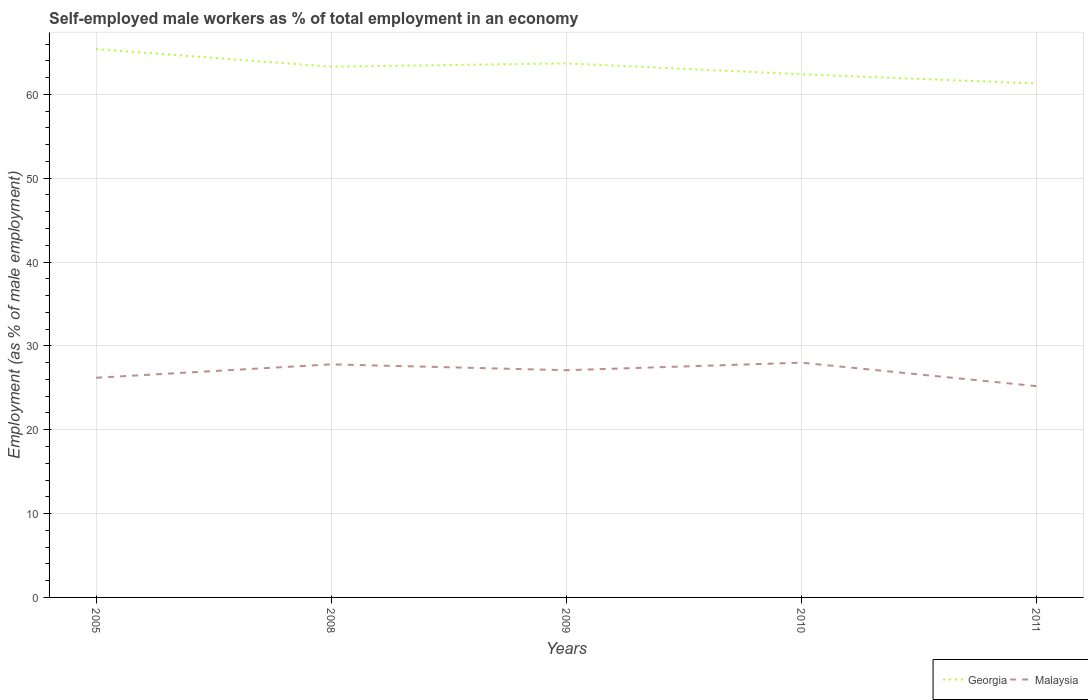Does the line corresponding to Georgia intersect with the line corresponding to Malaysia?
Offer a very short reply. No. Is the number of lines equal to the number of legend labels?
Ensure brevity in your answer.  Yes. Across all years, what is the maximum percentage of self-employed male workers in Malaysia?
Offer a very short reply. 25.2. In which year was the percentage of self-employed male workers in Malaysia maximum?
Your response must be concise. 2011. What is the total percentage of self-employed male workers in Georgia in the graph?
Ensure brevity in your answer.  2.1. What is the difference between the highest and the second highest percentage of self-employed male workers in Georgia?
Your response must be concise. 4.1. How many lines are there?
Offer a terse response. 2. Does the graph contain grids?
Provide a short and direct response. Yes. Where does the legend appear in the graph?
Offer a very short reply. Bottom right. What is the title of the graph?
Your answer should be compact. Self-employed male workers as % of total employment in an economy. Does "South Africa" appear as one of the legend labels in the graph?
Make the answer very short. No. What is the label or title of the X-axis?
Give a very brief answer. Years. What is the label or title of the Y-axis?
Provide a short and direct response. Employment (as % of male employment). What is the Employment (as % of male employment) of Georgia in 2005?
Your answer should be compact. 65.4. What is the Employment (as % of male employment) of Malaysia in 2005?
Ensure brevity in your answer.  26.2. What is the Employment (as % of male employment) of Georgia in 2008?
Offer a terse response. 63.3. What is the Employment (as % of male employment) in Malaysia in 2008?
Provide a short and direct response. 27.8. What is the Employment (as % of male employment) in Georgia in 2009?
Your response must be concise. 63.7. What is the Employment (as % of male employment) of Malaysia in 2009?
Provide a short and direct response. 27.1. What is the Employment (as % of male employment) of Georgia in 2010?
Keep it short and to the point. 62.4. What is the Employment (as % of male employment) of Georgia in 2011?
Provide a succinct answer. 61.3. What is the Employment (as % of male employment) of Malaysia in 2011?
Your response must be concise. 25.2. Across all years, what is the maximum Employment (as % of male employment) in Georgia?
Your answer should be very brief. 65.4. Across all years, what is the minimum Employment (as % of male employment) of Georgia?
Give a very brief answer. 61.3. Across all years, what is the minimum Employment (as % of male employment) in Malaysia?
Make the answer very short. 25.2. What is the total Employment (as % of male employment) in Georgia in the graph?
Your answer should be compact. 316.1. What is the total Employment (as % of male employment) of Malaysia in the graph?
Provide a short and direct response. 134.3. What is the difference between the Employment (as % of male employment) of Georgia in 2005 and that in 2008?
Give a very brief answer. 2.1. What is the difference between the Employment (as % of male employment) in Malaysia in 2005 and that in 2009?
Provide a short and direct response. -0.9. What is the difference between the Employment (as % of male employment) of Malaysia in 2005 and that in 2010?
Your answer should be compact. -1.8. What is the difference between the Employment (as % of male employment) of Malaysia in 2005 and that in 2011?
Keep it short and to the point. 1. What is the difference between the Employment (as % of male employment) in Georgia in 2008 and that in 2009?
Give a very brief answer. -0.4. What is the difference between the Employment (as % of male employment) in Georgia in 2008 and that in 2010?
Provide a succinct answer. 0.9. What is the difference between the Employment (as % of male employment) in Georgia in 2008 and that in 2011?
Provide a succinct answer. 2. What is the difference between the Employment (as % of male employment) in Malaysia in 2009 and that in 2011?
Your response must be concise. 1.9. What is the difference between the Employment (as % of male employment) in Georgia in 2005 and the Employment (as % of male employment) in Malaysia in 2008?
Keep it short and to the point. 37.6. What is the difference between the Employment (as % of male employment) of Georgia in 2005 and the Employment (as % of male employment) of Malaysia in 2009?
Offer a very short reply. 38.3. What is the difference between the Employment (as % of male employment) of Georgia in 2005 and the Employment (as % of male employment) of Malaysia in 2010?
Your answer should be very brief. 37.4. What is the difference between the Employment (as % of male employment) in Georgia in 2005 and the Employment (as % of male employment) in Malaysia in 2011?
Make the answer very short. 40.2. What is the difference between the Employment (as % of male employment) of Georgia in 2008 and the Employment (as % of male employment) of Malaysia in 2009?
Provide a short and direct response. 36.2. What is the difference between the Employment (as % of male employment) in Georgia in 2008 and the Employment (as % of male employment) in Malaysia in 2010?
Your answer should be very brief. 35.3. What is the difference between the Employment (as % of male employment) of Georgia in 2008 and the Employment (as % of male employment) of Malaysia in 2011?
Provide a succinct answer. 38.1. What is the difference between the Employment (as % of male employment) in Georgia in 2009 and the Employment (as % of male employment) in Malaysia in 2010?
Ensure brevity in your answer.  35.7. What is the difference between the Employment (as % of male employment) in Georgia in 2009 and the Employment (as % of male employment) in Malaysia in 2011?
Keep it short and to the point. 38.5. What is the difference between the Employment (as % of male employment) in Georgia in 2010 and the Employment (as % of male employment) in Malaysia in 2011?
Offer a terse response. 37.2. What is the average Employment (as % of male employment) of Georgia per year?
Offer a very short reply. 63.22. What is the average Employment (as % of male employment) of Malaysia per year?
Keep it short and to the point. 26.86. In the year 2005, what is the difference between the Employment (as % of male employment) of Georgia and Employment (as % of male employment) of Malaysia?
Your response must be concise. 39.2. In the year 2008, what is the difference between the Employment (as % of male employment) in Georgia and Employment (as % of male employment) in Malaysia?
Make the answer very short. 35.5. In the year 2009, what is the difference between the Employment (as % of male employment) of Georgia and Employment (as % of male employment) of Malaysia?
Your response must be concise. 36.6. In the year 2010, what is the difference between the Employment (as % of male employment) in Georgia and Employment (as % of male employment) in Malaysia?
Ensure brevity in your answer.  34.4. In the year 2011, what is the difference between the Employment (as % of male employment) in Georgia and Employment (as % of male employment) in Malaysia?
Make the answer very short. 36.1. What is the ratio of the Employment (as % of male employment) of Georgia in 2005 to that in 2008?
Your response must be concise. 1.03. What is the ratio of the Employment (as % of male employment) of Malaysia in 2005 to that in 2008?
Provide a short and direct response. 0.94. What is the ratio of the Employment (as % of male employment) in Georgia in 2005 to that in 2009?
Your answer should be very brief. 1.03. What is the ratio of the Employment (as % of male employment) of Malaysia in 2005 to that in 2009?
Provide a succinct answer. 0.97. What is the ratio of the Employment (as % of male employment) of Georgia in 2005 to that in 2010?
Your answer should be very brief. 1.05. What is the ratio of the Employment (as % of male employment) of Malaysia in 2005 to that in 2010?
Provide a short and direct response. 0.94. What is the ratio of the Employment (as % of male employment) in Georgia in 2005 to that in 2011?
Your response must be concise. 1.07. What is the ratio of the Employment (as % of male employment) of Malaysia in 2005 to that in 2011?
Offer a terse response. 1.04. What is the ratio of the Employment (as % of male employment) in Malaysia in 2008 to that in 2009?
Your answer should be compact. 1.03. What is the ratio of the Employment (as % of male employment) of Georgia in 2008 to that in 2010?
Offer a terse response. 1.01. What is the ratio of the Employment (as % of male employment) in Georgia in 2008 to that in 2011?
Give a very brief answer. 1.03. What is the ratio of the Employment (as % of male employment) in Malaysia in 2008 to that in 2011?
Give a very brief answer. 1.1. What is the ratio of the Employment (as % of male employment) in Georgia in 2009 to that in 2010?
Give a very brief answer. 1.02. What is the ratio of the Employment (as % of male employment) of Malaysia in 2009 to that in 2010?
Offer a very short reply. 0.97. What is the ratio of the Employment (as % of male employment) of Georgia in 2009 to that in 2011?
Your answer should be very brief. 1.04. What is the ratio of the Employment (as % of male employment) in Malaysia in 2009 to that in 2011?
Provide a short and direct response. 1.08. What is the ratio of the Employment (as % of male employment) of Georgia in 2010 to that in 2011?
Give a very brief answer. 1.02. What is the difference between the highest and the second highest Employment (as % of male employment) in Georgia?
Provide a succinct answer. 1.7. 